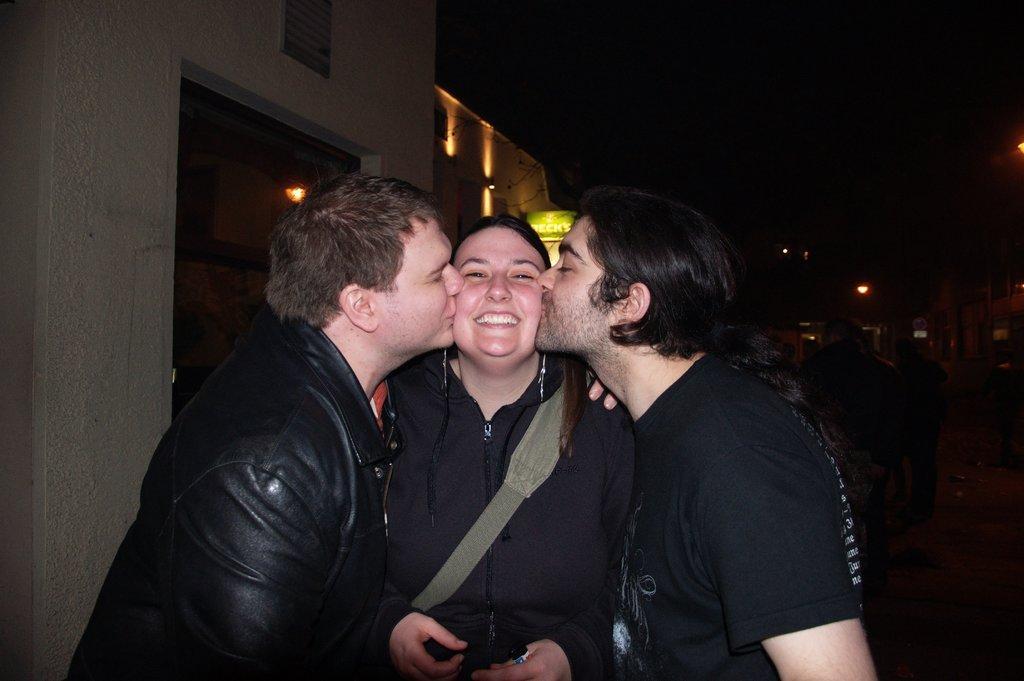In one or two sentences, can you explain what this image depicts? In this picture we can see two men and one woman where woman is smiling and two men are kissing her and in the background we can see building with windows, lights and it is dark. 